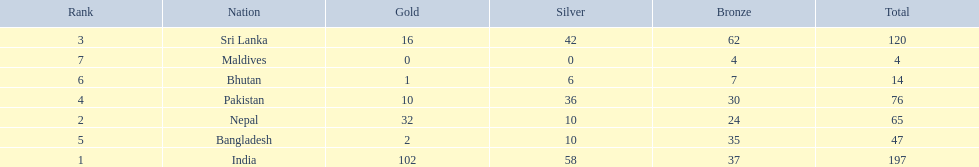How many gold medals were awarded between all 7 nations? 163. 